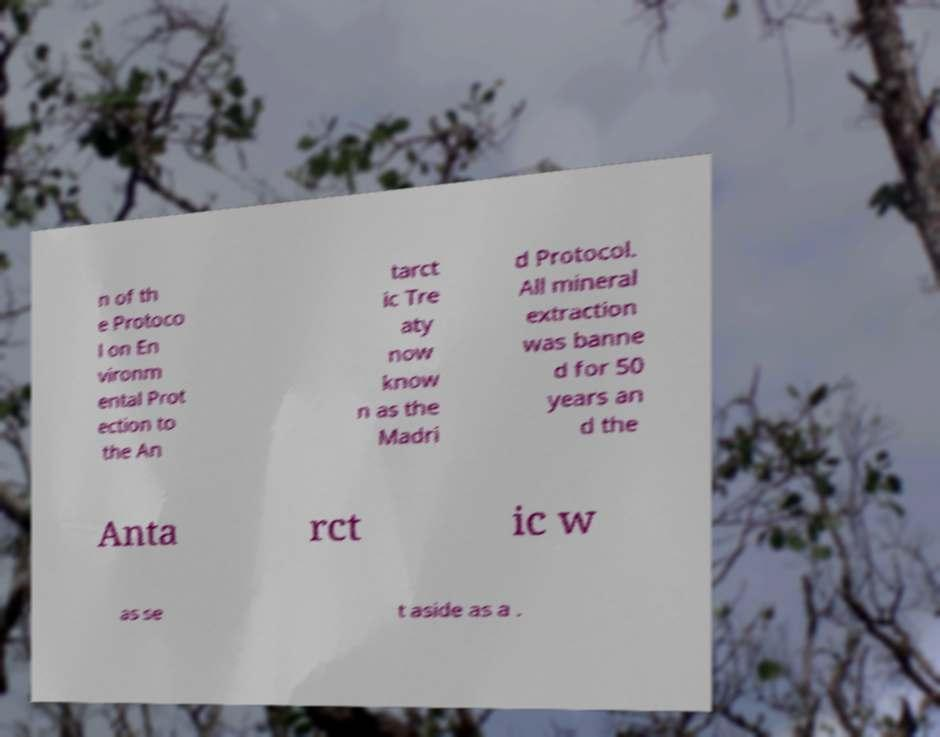Could you assist in decoding the text presented in this image and type it out clearly? n of th e Protoco l on En vironm ental Prot ection to the An tarct ic Tre aty now know n as the Madri d Protocol. All mineral extraction was banne d for 50 years an d the Anta rct ic w as se t aside as a . 